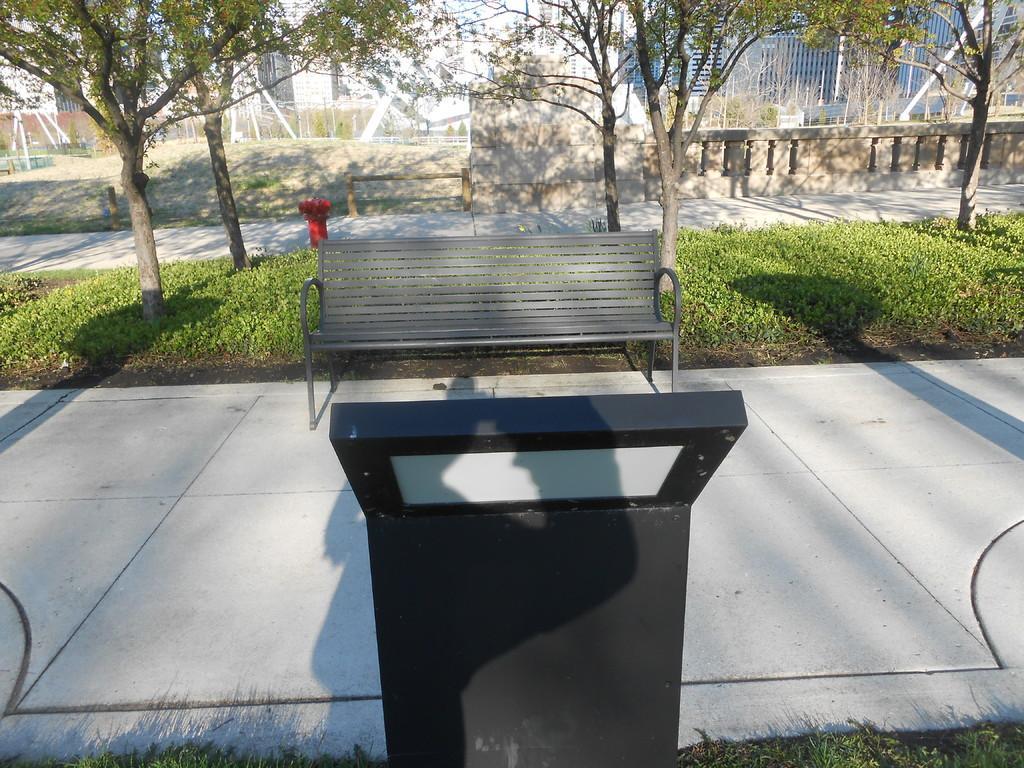Please provide a concise description of this image. In the middle of the image we can see a bench. Behind it grassy land is there and trees are present. Behind the trees, buildings are there. Bottom of the image one black color stand is present. 